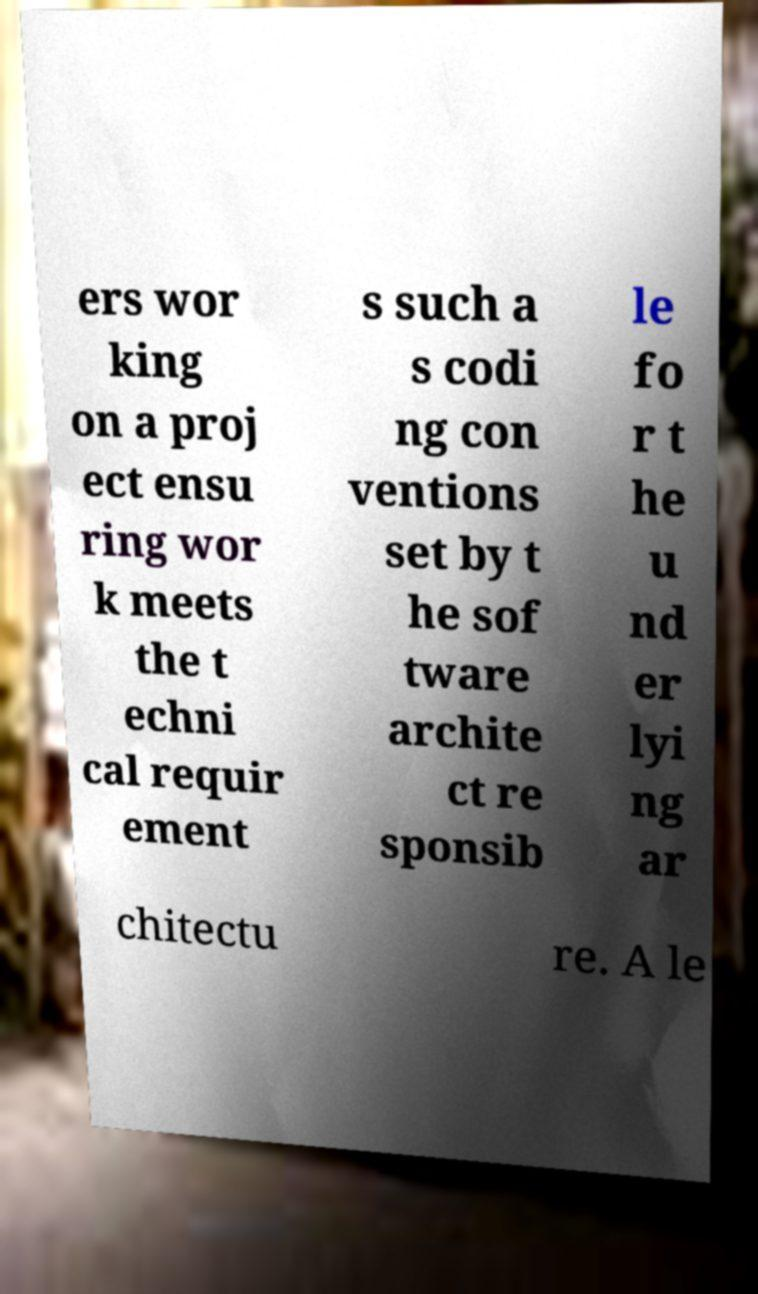Can you read and provide the text displayed in the image?This photo seems to have some interesting text. Can you extract and type it out for me? ers wor king on a proj ect ensu ring wor k meets the t echni cal requir ement s such a s codi ng con ventions set by t he sof tware archite ct re sponsib le fo r t he u nd er lyi ng ar chitectu re. A le 